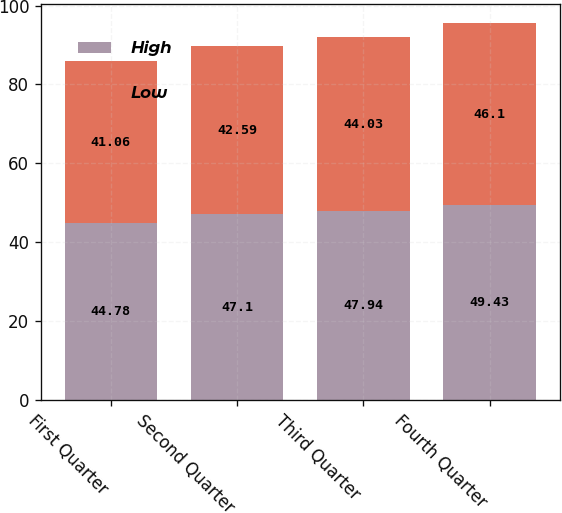Convert chart. <chart><loc_0><loc_0><loc_500><loc_500><stacked_bar_chart><ecel><fcel>First Quarter<fcel>Second Quarter<fcel>Third Quarter<fcel>Fourth Quarter<nl><fcel>High<fcel>44.78<fcel>47.1<fcel>47.94<fcel>49.43<nl><fcel>Low<fcel>41.06<fcel>42.59<fcel>44.03<fcel>46.1<nl></chart> 